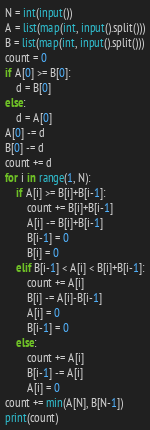Convert code to text. <code><loc_0><loc_0><loc_500><loc_500><_Python_>N = int(input())
A = list(map(int, input().split()))
B = list(map(int, input().split()))
count = 0
if A[0] >= B[0]:
    d = B[0]
else:
    d = A[0]
A[0] -= d
B[0] -= d
count += d
for i in range(1, N):
    if A[i] >= B[i]+B[i-1]:
        count += B[i]+B[i-1]
        A[i] -= B[i]+B[i-1]
        B[i-1] = 0
        B[i] = 0
    elif B[i-1] < A[i] < B[i]+B[i-1]:
        count += A[i]
        B[i] -= A[i]-B[i-1]
        A[i] = 0
        B[i-1] = 0
    else:
        count += A[i]
        B[i-1] -= A[i]
        A[i] = 0
count += min(A[N], B[N-1]) 
print(count)</code> 